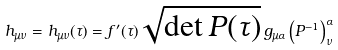Convert formula to latex. <formula><loc_0><loc_0><loc_500><loc_500>h _ { \mu \nu } = h _ { \mu \nu } ( \tau ) = f ^ { \prime } ( \tau ) \sqrt { \det P ( \tau ) } \, g _ { \mu \alpha } \left ( P ^ { - 1 } \right ) _ { \nu } ^ { \alpha }</formula> 